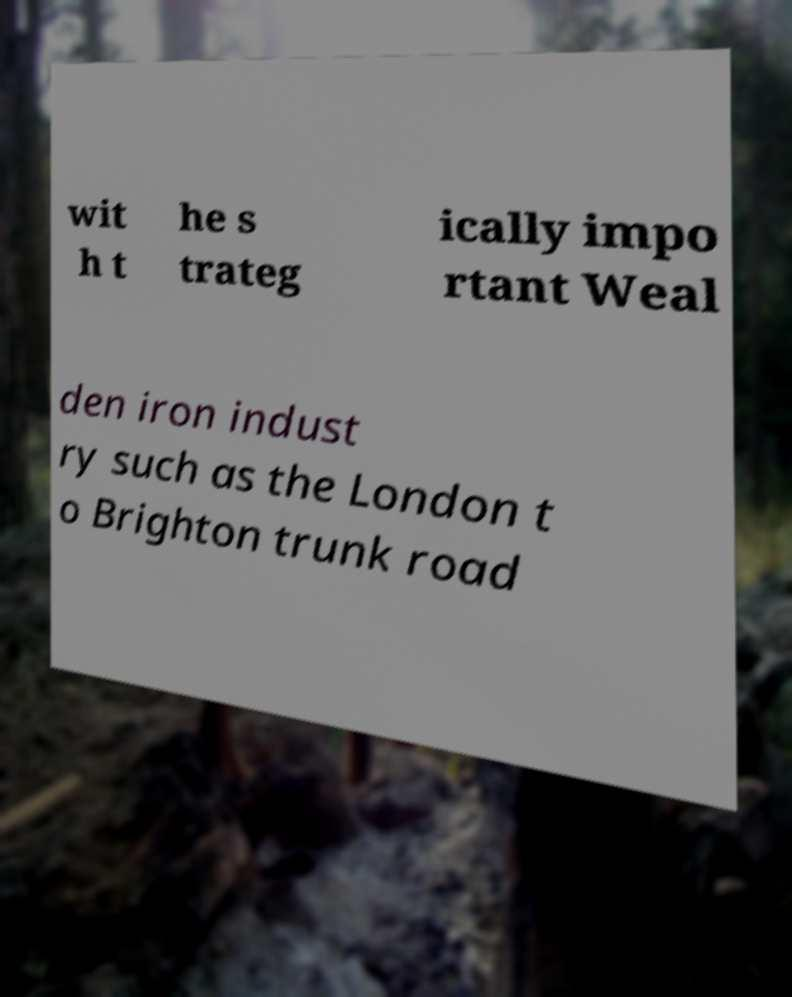Can you read and provide the text displayed in the image?This photo seems to have some interesting text. Can you extract and type it out for me? wit h t he s trateg ically impo rtant Weal den iron indust ry such as the London t o Brighton trunk road 